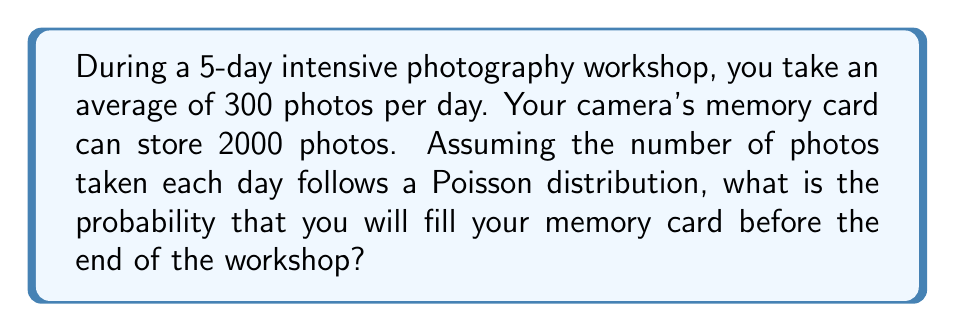Solve this math problem. Let's approach this step-by-step:

1) First, we need to calculate the total number of photos expected to be taken during the workshop:
   $$ \text{Expected total} = 300 \text{ photos/day} \times 5 \text{ days} = 1500 \text{ photos} $$

2) The memory card capacity is 2000 photos, so we need to find the probability of taking more than 2000 photos in 5 days.

3) We're told that the number of photos taken each day follows a Poisson distribution. For a 5-day period, this will be a sum of 5 Poisson distributions, which is itself a Poisson distribution with a mean that's 5 times the daily mean.

4) The mean of our 5-day Poisson distribution is:
   $$ \lambda = 300 \times 5 = 1500 $$

5) We want to find $P(X > 2000)$ where $X$ is our Poisson random variable. This is equivalent to $1 - P(X \leq 2000)$.

6) For a Poisson distribution with large $\lambda$, we can use the normal approximation. The normal distribution that approximates our Poisson has:
   $$ \mu = \lambda = 1500 $$
   $$ \sigma = \sqrt{\lambda} = \sqrt{1500} \approx 38.73 $$

7) We need to find the z-score for 2000:
   $$ z = \frac{2000 - 1500}{38.73} \approx 12.91 $$

8) Using a standard normal table or calculator, we can find:
   $$ P(Z \leq 12.91) \approx 1 $$

9) Therefore, $P(X > 2000) = 1 - P(X \leq 2000) \approx 1 - 1 = 0$
Answer: $\approx 0$ 